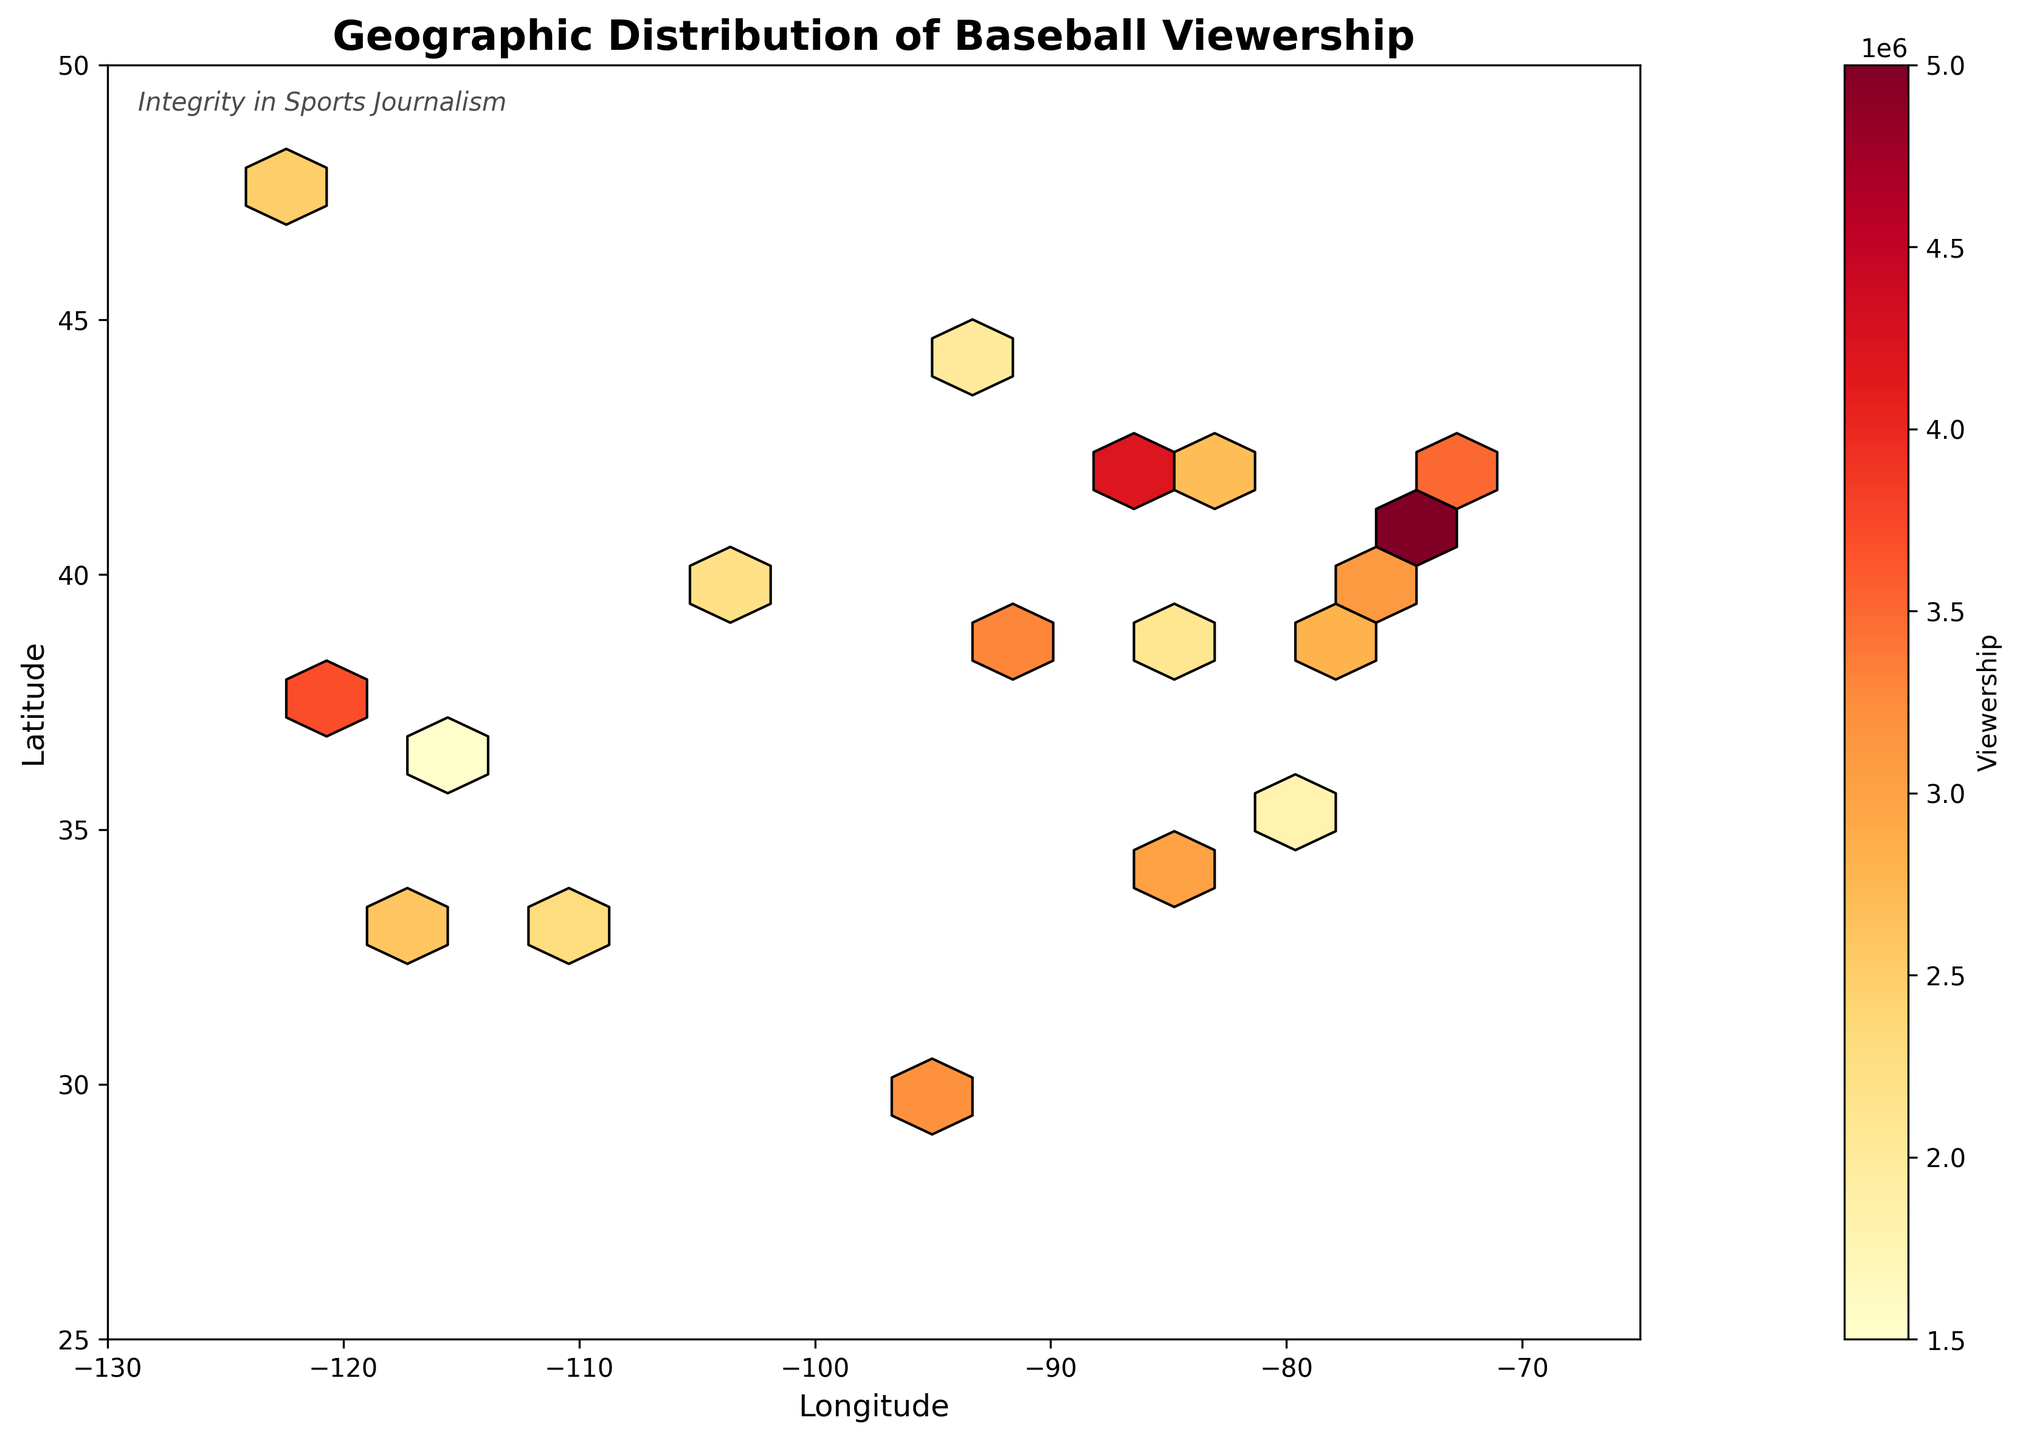What is the title of the plot? The title of the plot can be found at the top of the figure. It describes the overall message conveyed by the visual data.
Answer: Geographic Distribution of Baseball Viewership What does the color intensity represent on the hexbin plot? The color intensity represents the number of viewers in a specific geographic area. This can be inferred by looking at the color bar which labels the viewership.
Answer: Viewership Which geographic region has the highest viewership? The region with the deepest (most intense) yellow or red color indicates the highest viewership. By examining these colors, we can determine the region with the highest concentration.
Answer: East Coast (New York area) What are the axes labels on the plot? The axes labels describe what each axis signifies in the plot. They are located along the horizontal and vertical lines flanking the plot area.
Answer: Longitude and Latitude Is there any annotation or extra text on the plot? Extra text or annotation is usually added to provide additional context or insight and is often placed within the plot area or its margins.
Answer: Integrity in Sports Journalism Do the hexbin cells extend beyond the geographical boundaries of the United States? The hexbin plot is restricted by specific latitude and longitude limits to represent the data accurately. This boundary jump can be checked by comparing plot limits with known geographical boundaries of the USA.
Answer: No Which city has a viewership of over 4 million? Specific data points can be highlighted in a hexbin plot through concentrated colored cells. The legend and axes can be used to cross-reference the location with given viewership details to identify the city with over 4 million viewers.
Answer: Chicago How does viewership compare between the West Coast and the East Coast? By comparing the color intensities on the West and East Coasts, a determination can be made about which side of the country has more viewers based on hex color ranking.
Answer: East Coast has higher viewership What geographic coordinates exhibit the smallest viewership? The analysis involves looking for the areas with the lightest color intensity in the hexbin plot which correlates low viewership, identifiable through the color key.
Answer: 36.1699,-115.1398 (Las Vegas) Which geographic region has the densest cluster of data points? By scanning the plot for areas with dense clusters of hexagon cells, the region with the most tightly packed points can be identified. This information can then assess concentration density.
Answer: East Coast, particularly around New York 